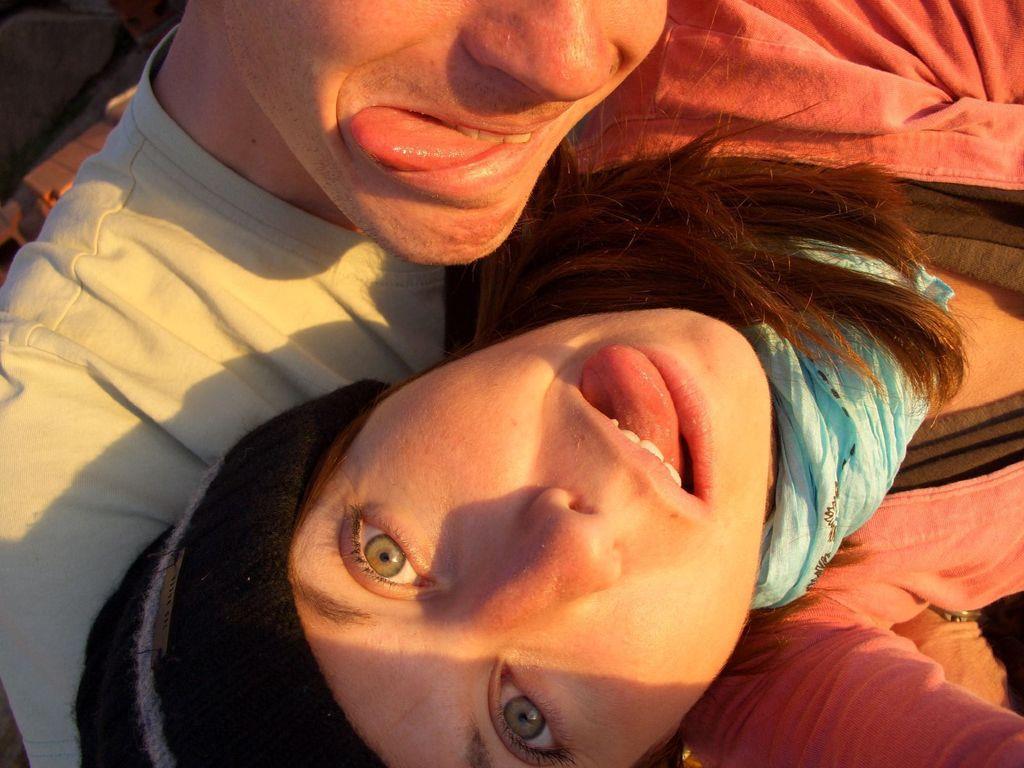In one or two sentences, can you explain what this image depicts? In this image there are two persons who kept their tongue outside. 